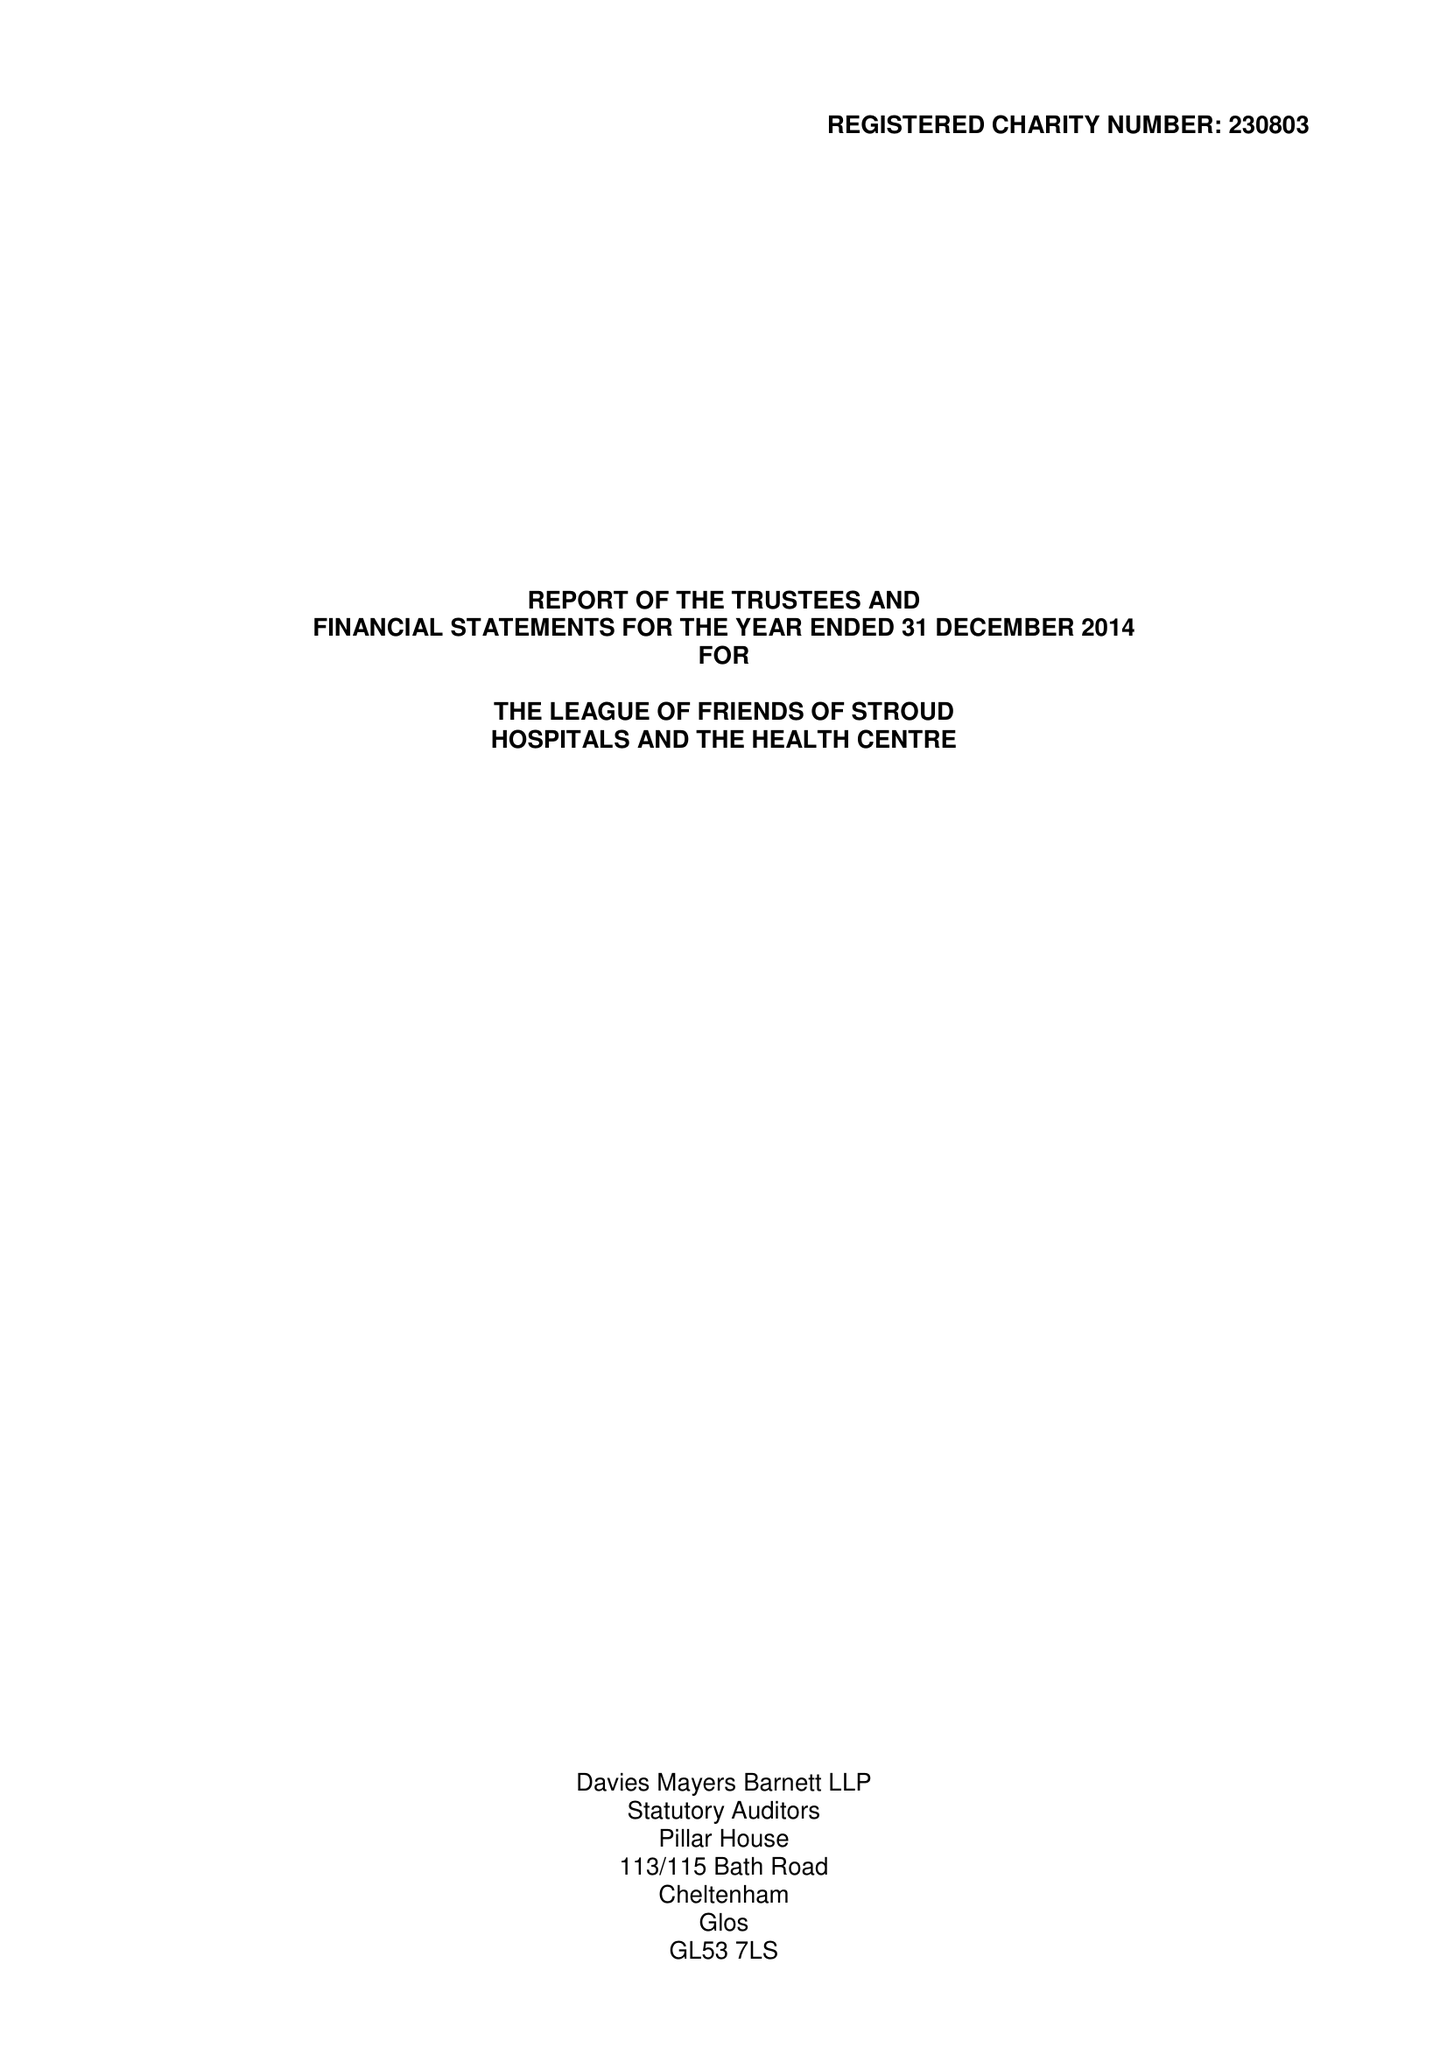What is the value for the address__post_town?
Answer the question using a single word or phrase. STROUD 